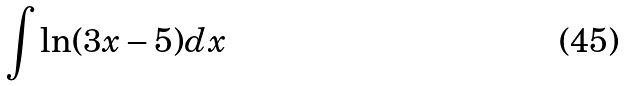<formula> <loc_0><loc_0><loc_500><loc_500>\int \ln ( 3 x - 5 ) d x</formula> 